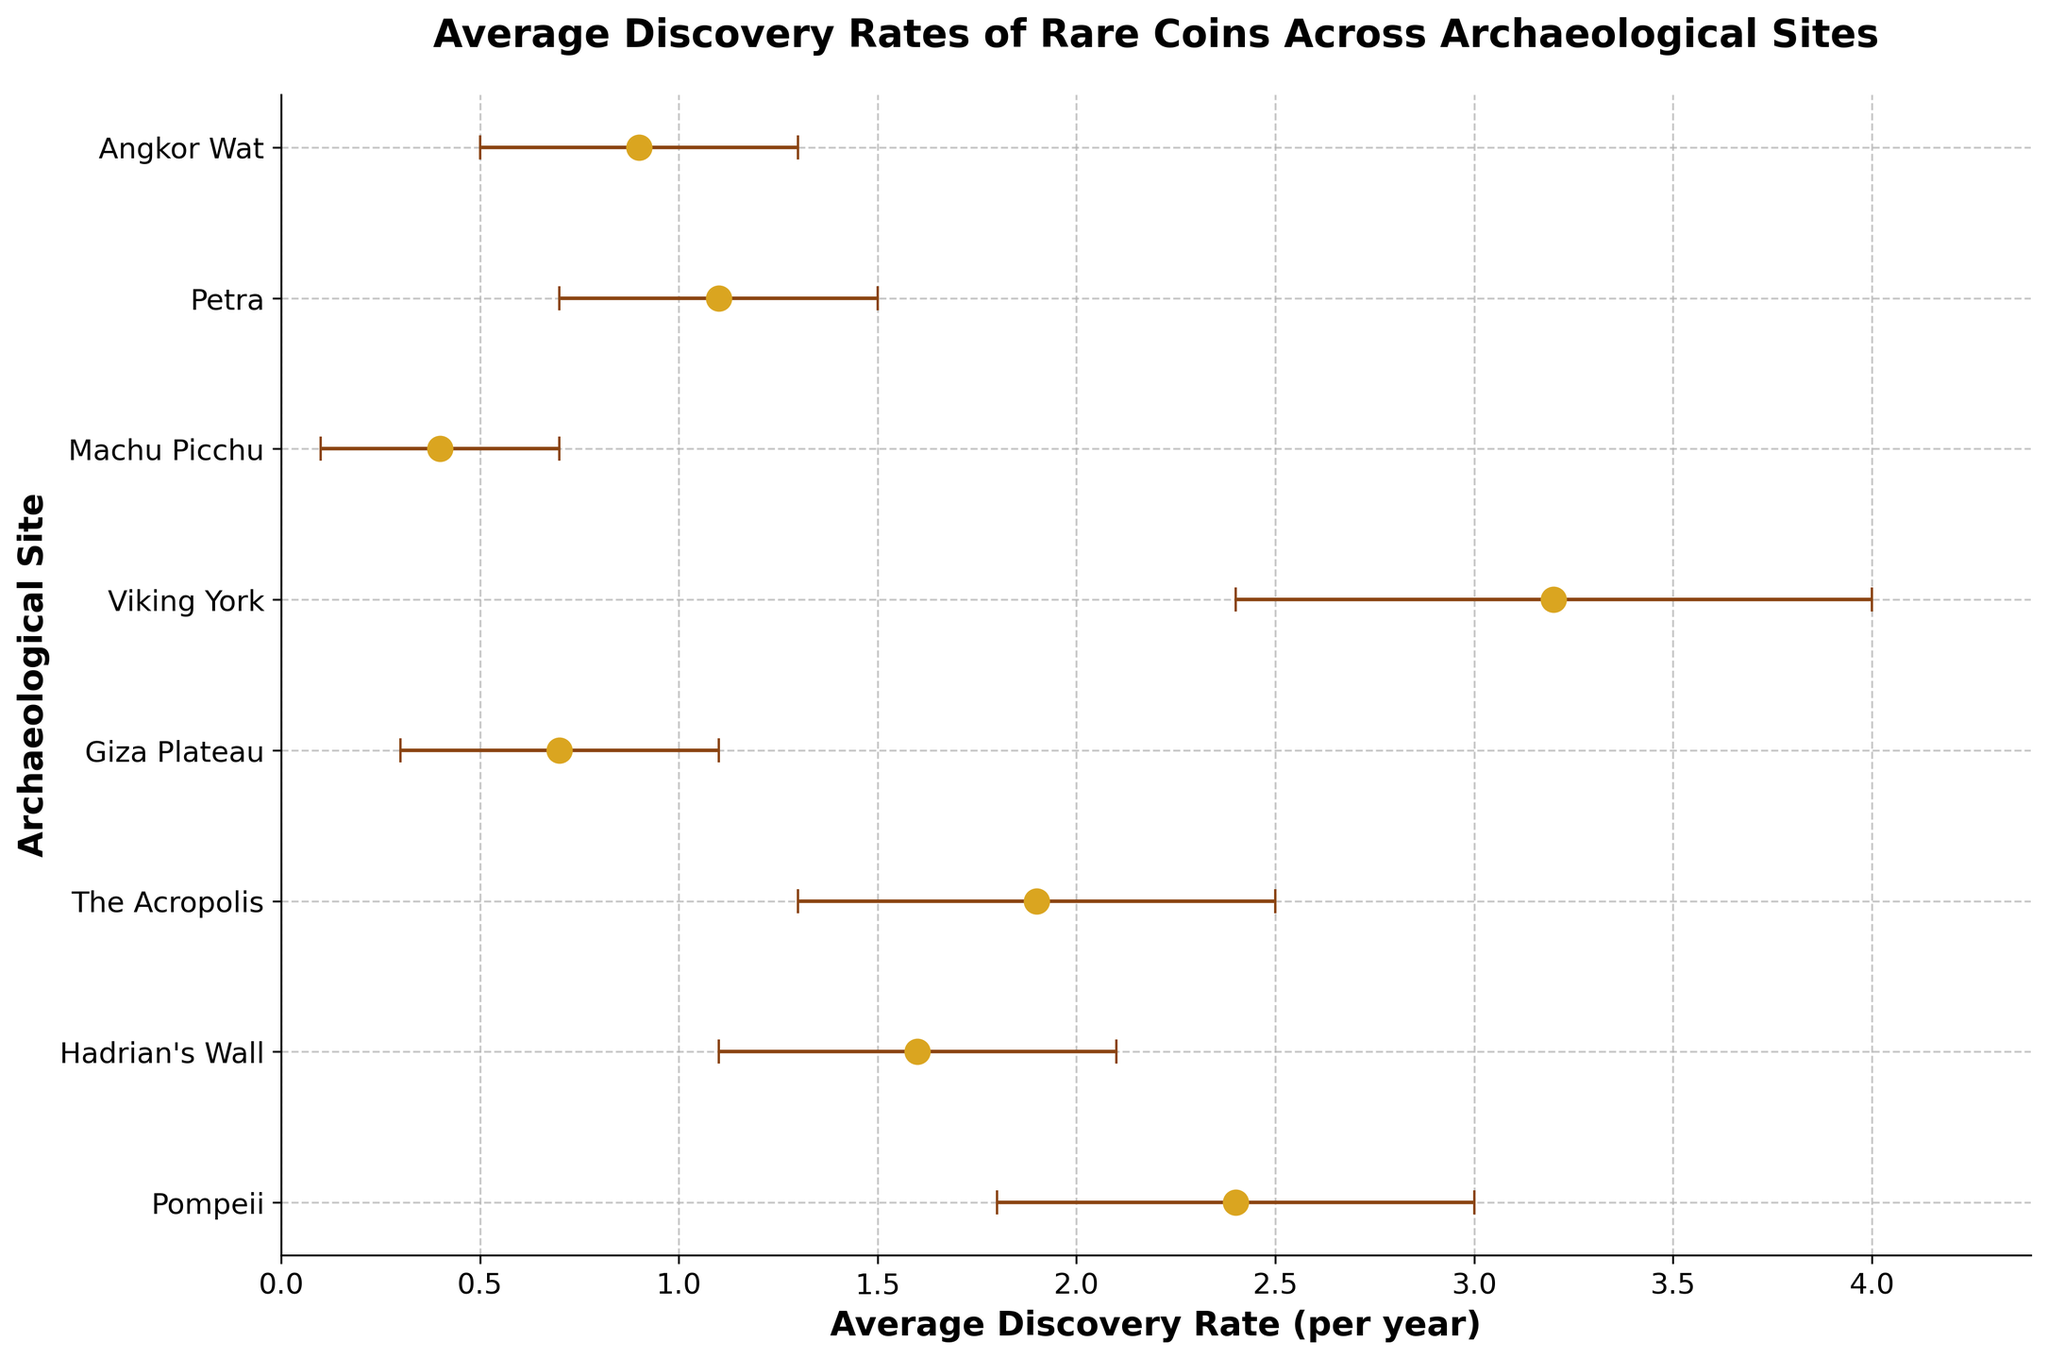Which archaeological site has the highest average discovery rate of rare coins? To determine this, identify the site with the highest value on the x-axis for average discovery rate. Viking York has the highest rate at 3.2 coins per year.
Answer: Viking York What is the average discovery rate of rare coins at Machu Picchu? Look for Machu Picchu on the y-axis and trace it to the x-axis for its average discovery rate. Machu Picchu has an average discovery rate of 0.4 coins per year.
Answer: 0.4 coins per year What's the range of the confidence interval for rare coin discovery at Giza Plateau? Identify Giza Plateau on the y-axis and check its lower and upper confidence intervals on the x-axis. The lower bound is 0.3, and the upper bound is 1.1. Thus, the range is 1.1 - 0.3 = 0.8.
Answer: 0.8 Which site has the smallest margin of error in its confidence interval for rare coin discovery and what is it? Calculate the margin of error for each site by subtracting the lower confidence interval from the upper confidence interval, then find the smallest difference. Petra has the smallest margin of error, where 1.5 - 0.7 = 0.8.
Answer: Petra, 0.8 How much higher is the average discovery rate at Pompeii compared to Hadrian's Wall? Identify the average discovery rates and subtract Hadrian's Wall's rate from Pompeii's rate. Pompeii has 2.4 coins per year, and Hadrian's Wall has 1.6 coins per year. So, 2.4 - 1.6 = 0.8.
Answer: 0.8 coins per year If you average the discovery rates of the sites with the top three highest rates, what value do you get? Identify the three highest rates (Viking York: 3.2, Pompeii: 2.4, The Acropolis: 1.9), sum them, and divide by three. (3.2 + 2.4 + 1.9) / 3 = 7.5 / 3 = 2.5
Answer: 2.5 coins per year Which two archaeological sites have overlapping confidence intervals? Check the intervals of each site to see which ranges intersect. Pompeii (1.8-3.0) and The Acropolis (1.3-2.5), Hadrian's Wall (1.1-2.1) and The Acropolis (1.3-2.5) overlap.
Answer: Pompeii & The Acropolis, Hadrian's Wall & The Acropolis Which site has the lowest average discovery rate and how low is it? Find the site with the smallest value on the x-axis for average discovery rate. Machu Picchu has the lowest average rate of 0.4 coins per year.
Answer: Machu Picchu, 0.4 coins per year 